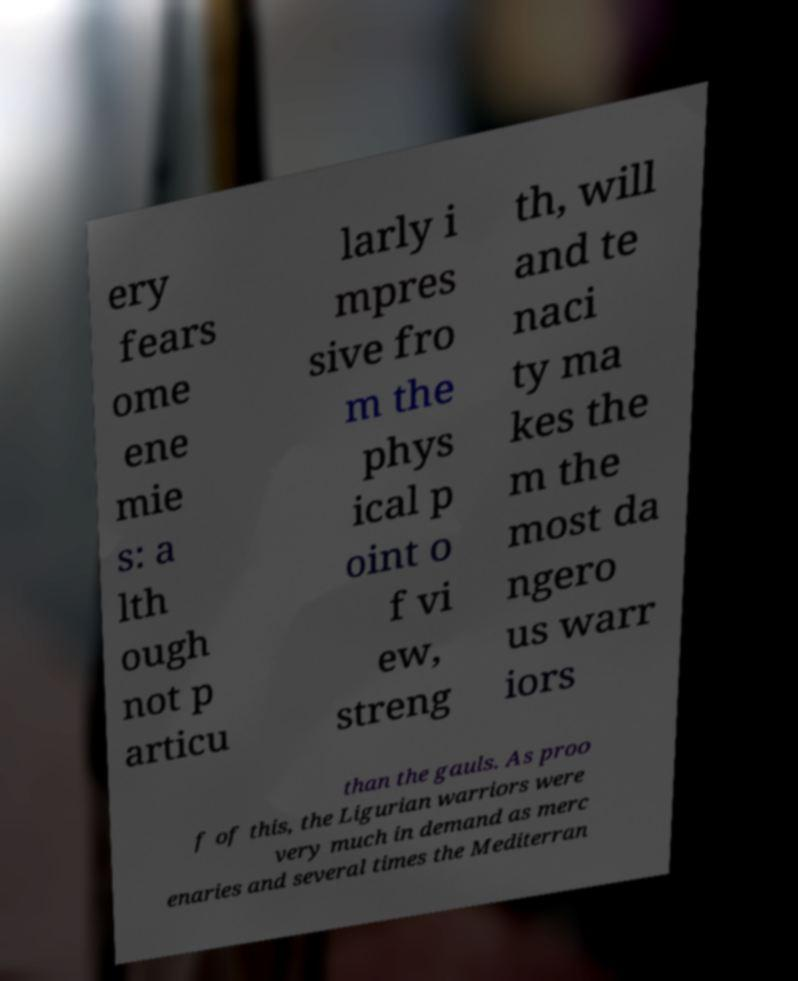What messages or text are displayed in this image? I need them in a readable, typed format. ery fears ome ene mie s: a lth ough not p articu larly i mpres sive fro m the phys ical p oint o f vi ew, streng th, will and te naci ty ma kes the m the most da ngero us warr iors than the gauls. As proo f of this, the Ligurian warriors were very much in demand as merc enaries and several times the Mediterran 